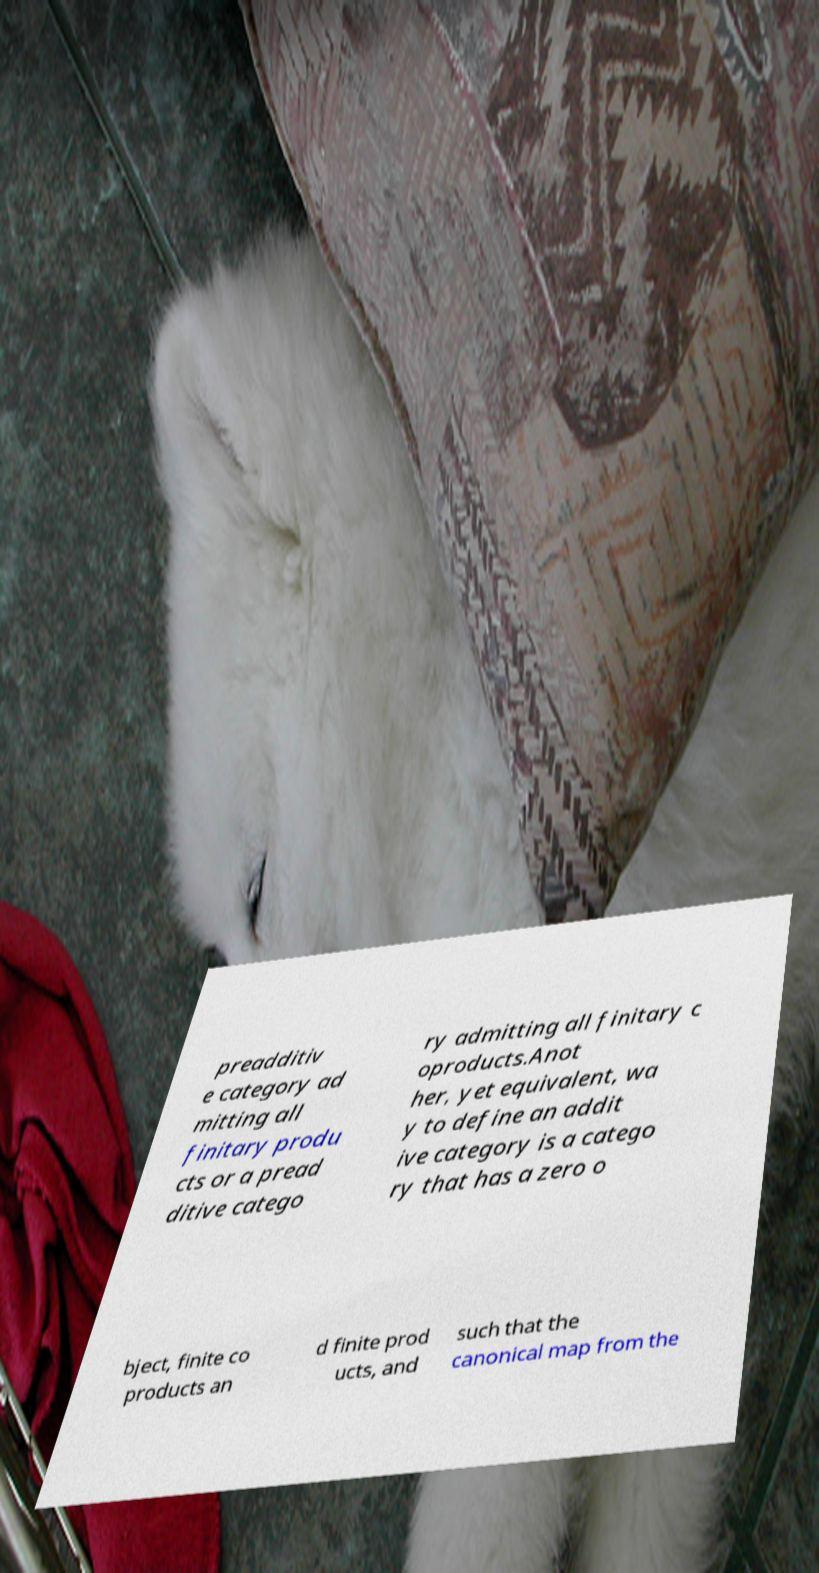There's text embedded in this image that I need extracted. Can you transcribe it verbatim? preadditiv e category ad mitting all finitary produ cts or a pread ditive catego ry admitting all finitary c oproducts.Anot her, yet equivalent, wa y to define an addit ive category is a catego ry that has a zero o bject, finite co products an d finite prod ucts, and such that the canonical map from the 